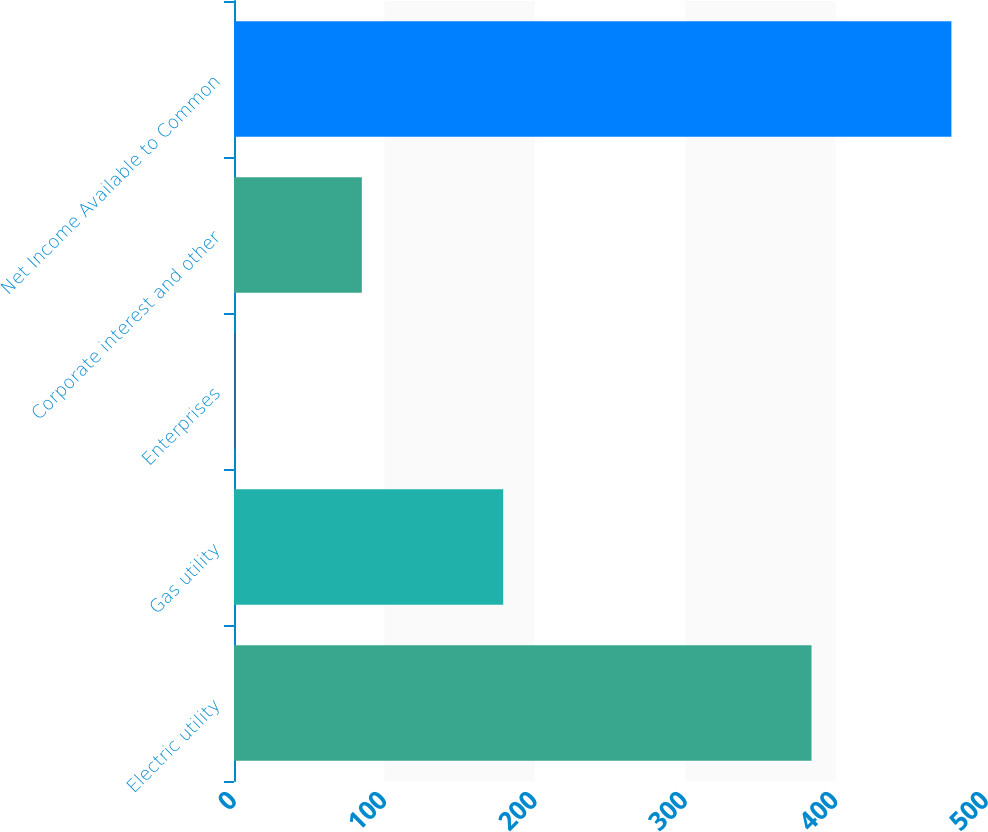<chart> <loc_0><loc_0><loc_500><loc_500><bar_chart><fcel>Electric utility<fcel>Gas utility<fcel>Enterprises<fcel>Corporate interest and other<fcel>Net Income Available to Common<nl><fcel>384<fcel>179<fcel>1<fcel>85<fcel>477<nl></chart> 